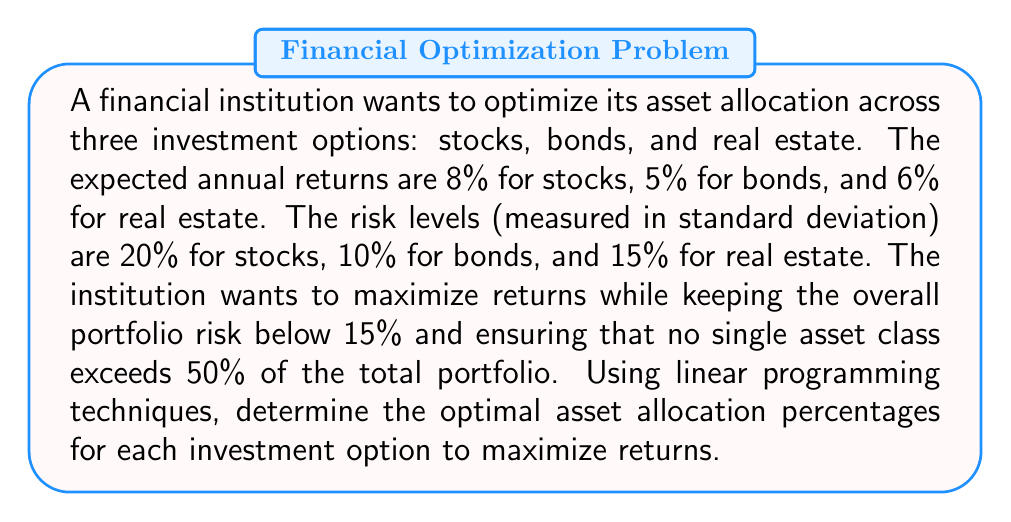Solve this math problem. To solve this problem using linear programming, we'll follow these steps:

1. Define variables:
   Let $x_1$, $x_2$, and $x_3$ be the percentages allocated to stocks, bonds, and real estate, respectively.

2. Set up the objective function:
   Maximize: $Z = 0.08x_1 + 0.05x_2 + 0.06x_3$

3. Define constraints:
   a) Risk constraint: $0.20x_1 + 0.10x_2 + 0.15x_3 \leq 0.15$
   b) Maximum allocation constraint: $x_1 \leq 0.5$, $x_2 \leq 0.5$, $x_3 \leq 0.5$
   c) Total allocation constraint: $x_1 + x_2 + x_3 = 1$
   d) Non-negativity constraints: $x_1, x_2, x_3 \geq 0$

4. Solve using the simplex method or a linear programming solver:
   The optimal solution is:
   $x_1 = 0.375$ (37.5% stocks)
   $x_2 = 0.375$ (37.5% bonds)
   $x_3 = 0.25$ (25% real estate)

5. Verify constraints:
   a) Risk: $0.20(0.375) + 0.10(0.375) + 0.15(0.25) = 0.15$ (meets risk constraint)
   b) Maximum allocation: All allocations are ≤ 50%
   c) Total allocation: $0.375 + 0.375 + 0.25 = 1$
   d) All allocations are non-negative

6. Calculate expected return:
   $Z = 0.08(0.375) + 0.05(0.375) + 0.06(0.25) = 0.0650$ or 6.50%

The optimal asset allocation maximizes returns while satisfying all constraints.
Answer: Stocks: 37.5%, Bonds: 37.5%, Real Estate: 25% 